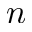<formula> <loc_0><loc_0><loc_500><loc_500>n</formula> 